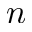<formula> <loc_0><loc_0><loc_500><loc_500>n</formula> 